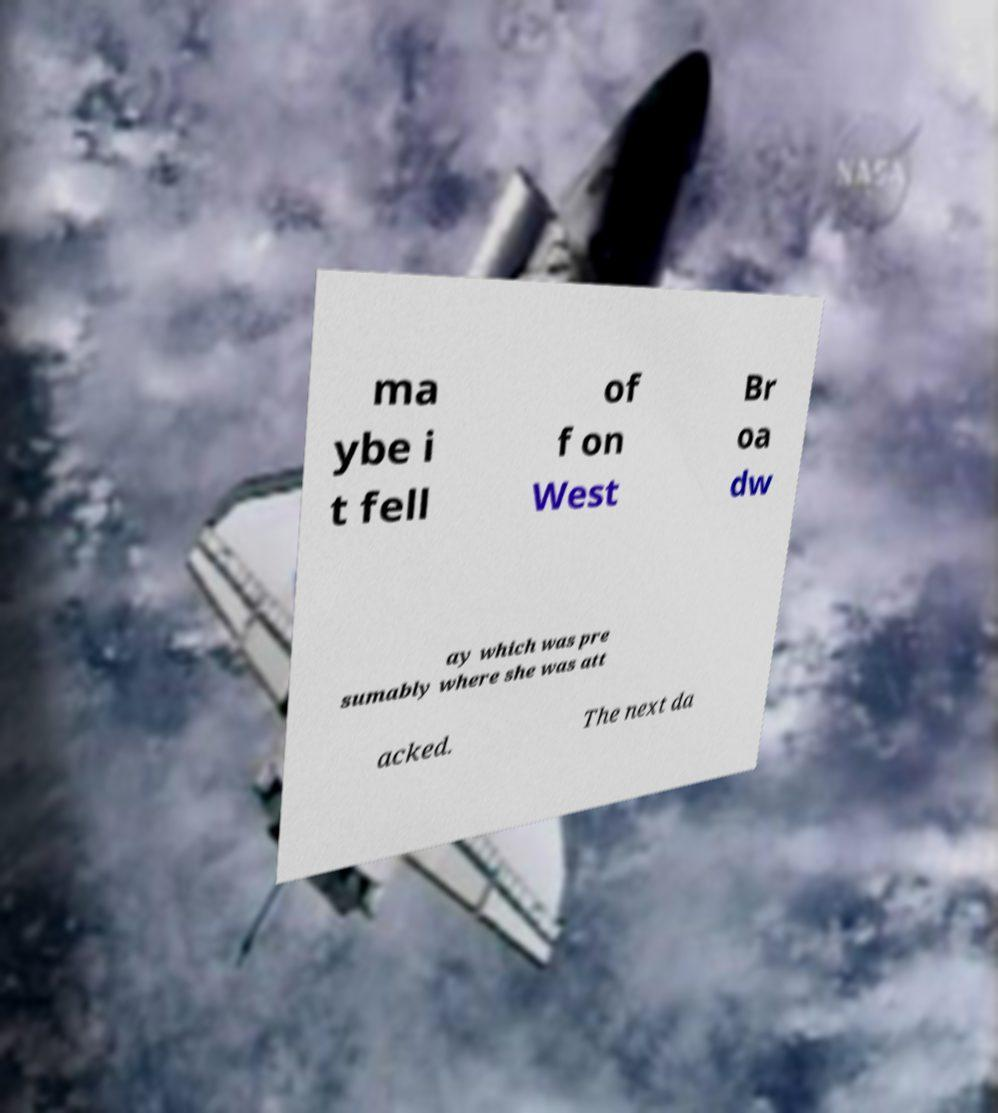Could you assist in decoding the text presented in this image and type it out clearly? ma ybe i t fell of f on West Br oa dw ay which was pre sumably where she was att acked. The next da 